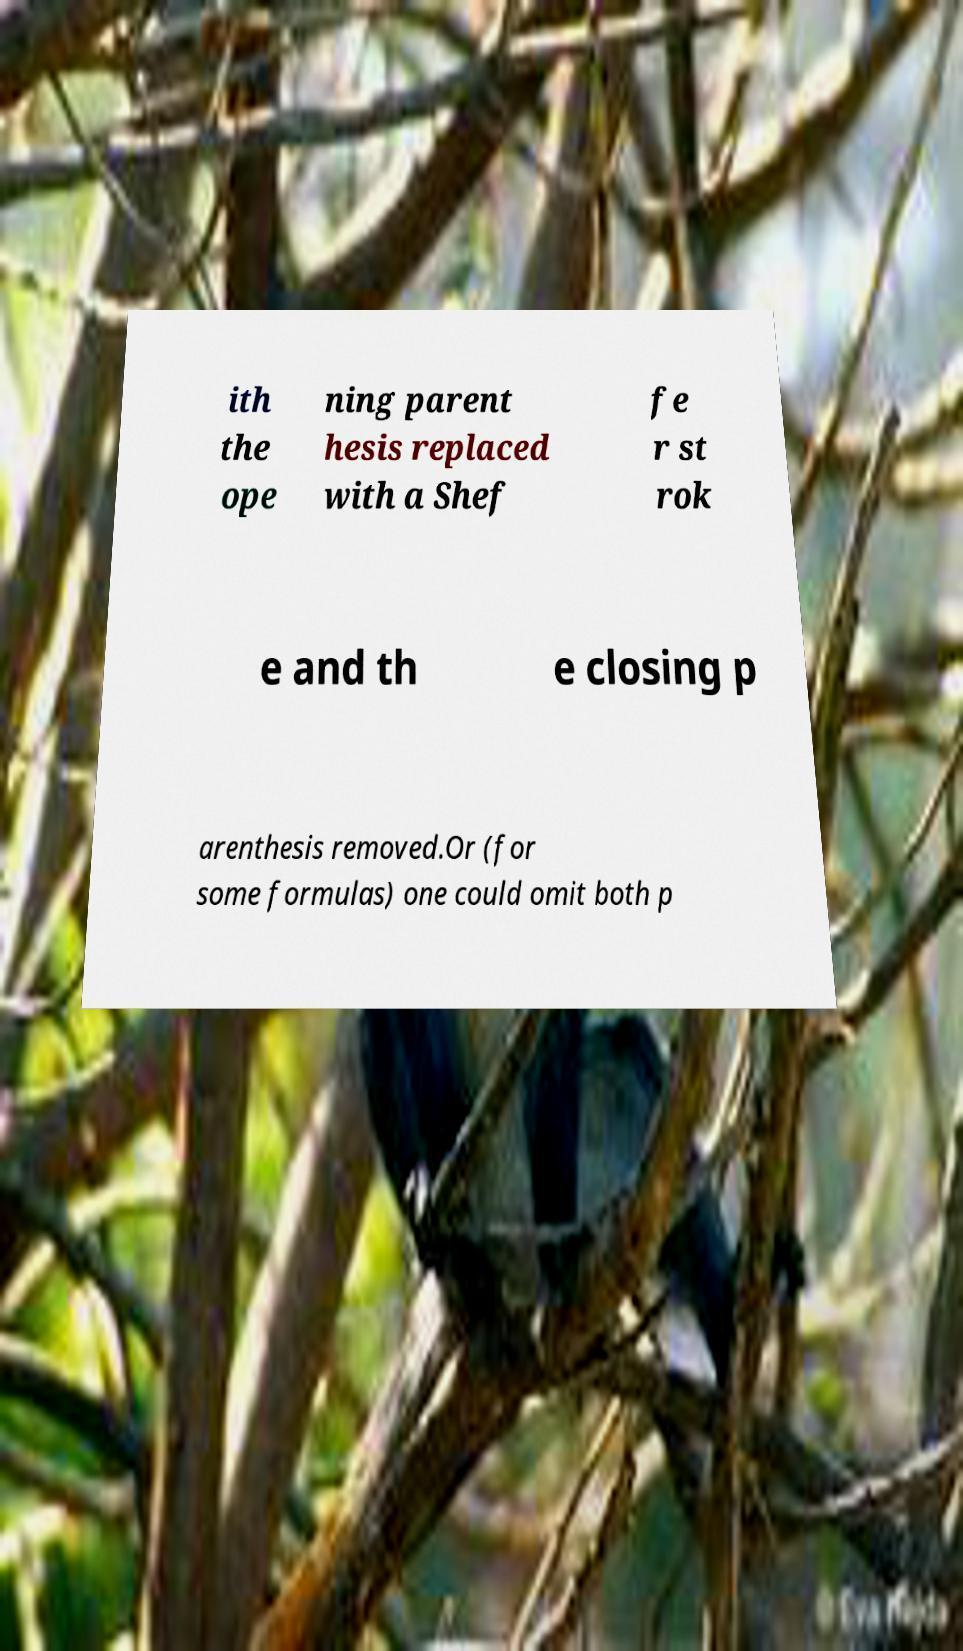Please identify and transcribe the text found in this image. ith the ope ning parent hesis replaced with a Shef fe r st rok e and th e closing p arenthesis removed.Or (for some formulas) one could omit both p 